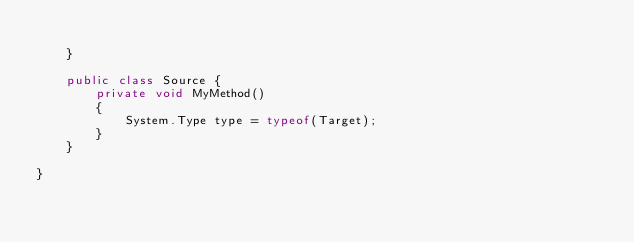Convert code to text. <code><loc_0><loc_0><loc_500><loc_500><_C#_>
    }

    public class Source {
        private void MyMethod()
        {
            System.Type type = typeof(Target);
        }
    }

}</code> 